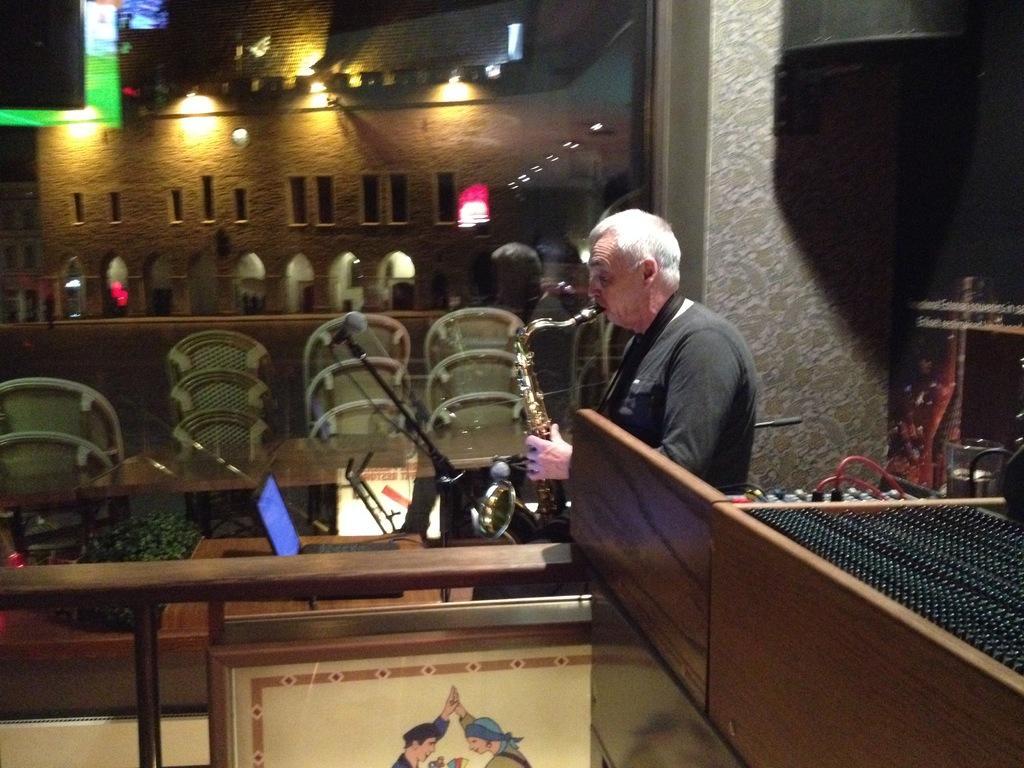Could you give a brief overview of what you see in this image? In this image we can see a person playing a musical instrument, there is a mic and a laptop on the table in front of the person, there is a frame an object looks like a music player beside the person and in the background we can see a reflection of chairs on the glass and we can see a building with lights through the glass. 